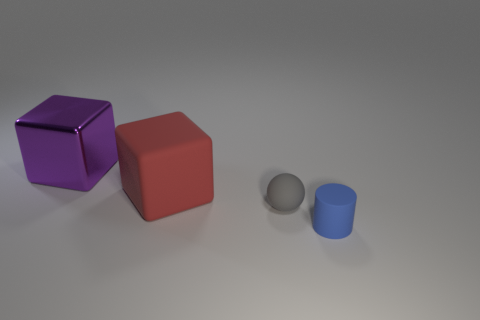Are there the same number of red blocks behind the large purple metallic object and red rubber cubes that are on the right side of the large matte cube? yes 